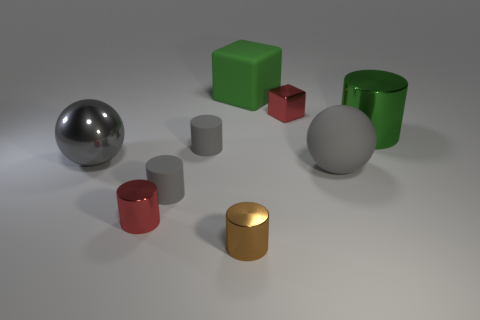Subtract all brown cylinders. How many cylinders are left? 4 Subtract all green metal cylinders. How many cylinders are left? 4 Subtract 1 cubes. How many cubes are left? 1 Subtract all cylinders. How many objects are left? 4 Subtract all yellow blocks. Subtract all red spheres. How many blocks are left? 2 Subtract all gray cubes. How many gray cylinders are left? 2 Subtract all green matte cubes. Subtract all small shiny objects. How many objects are left? 5 Add 2 big gray shiny things. How many big gray shiny things are left? 3 Add 8 large gray things. How many large gray things exist? 10 Subtract 2 gray spheres. How many objects are left? 7 